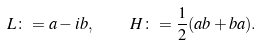<formula> <loc_0><loc_0><loc_500><loc_500>L \colon = a - i b , \quad H \colon = \frac { 1 } { 2 } ( a b + b a ) .</formula> 